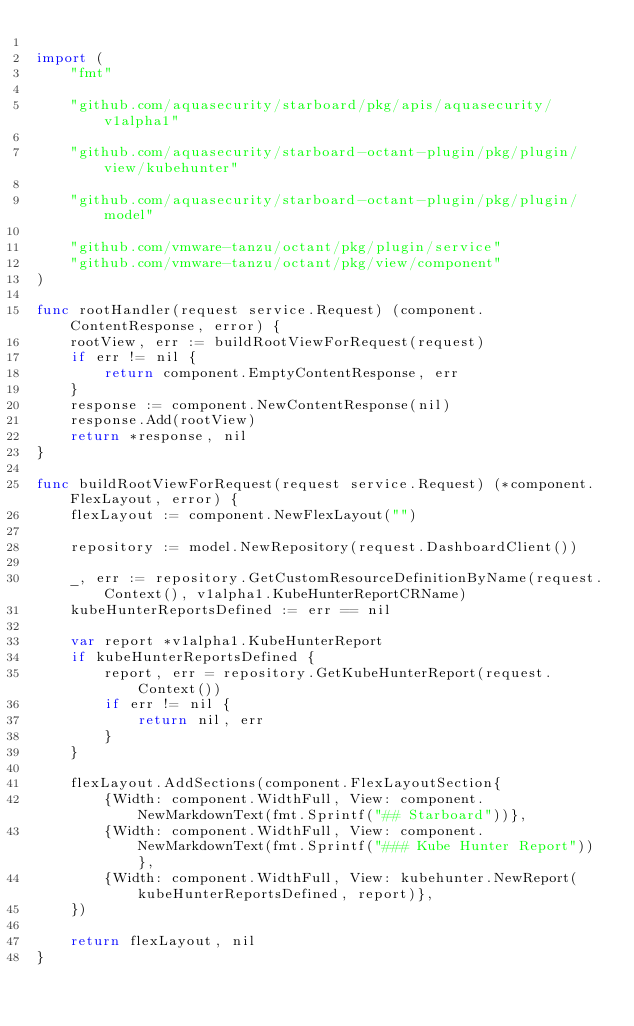<code> <loc_0><loc_0><loc_500><loc_500><_Go_>
import (
	"fmt"

	"github.com/aquasecurity/starboard/pkg/apis/aquasecurity/v1alpha1"

	"github.com/aquasecurity/starboard-octant-plugin/pkg/plugin/view/kubehunter"

	"github.com/aquasecurity/starboard-octant-plugin/pkg/plugin/model"

	"github.com/vmware-tanzu/octant/pkg/plugin/service"
	"github.com/vmware-tanzu/octant/pkg/view/component"
)

func rootHandler(request service.Request) (component.ContentResponse, error) {
	rootView, err := buildRootViewForRequest(request)
	if err != nil {
		return component.EmptyContentResponse, err
	}
	response := component.NewContentResponse(nil)
	response.Add(rootView)
	return *response, nil
}

func buildRootViewForRequest(request service.Request) (*component.FlexLayout, error) {
	flexLayout := component.NewFlexLayout("")

	repository := model.NewRepository(request.DashboardClient())

	_, err := repository.GetCustomResourceDefinitionByName(request.Context(), v1alpha1.KubeHunterReportCRName)
	kubeHunterReportsDefined := err == nil

	var report *v1alpha1.KubeHunterReport
	if kubeHunterReportsDefined {
		report, err = repository.GetKubeHunterReport(request.Context())
		if err != nil {
			return nil, err
		}
	}

	flexLayout.AddSections(component.FlexLayoutSection{
		{Width: component.WidthFull, View: component.NewMarkdownText(fmt.Sprintf("## Starboard"))},
		{Width: component.WidthFull, View: component.NewMarkdownText(fmt.Sprintf("### Kube Hunter Report"))},
		{Width: component.WidthFull, View: kubehunter.NewReport(kubeHunterReportsDefined, report)},
	})

	return flexLayout, nil
}
</code> 